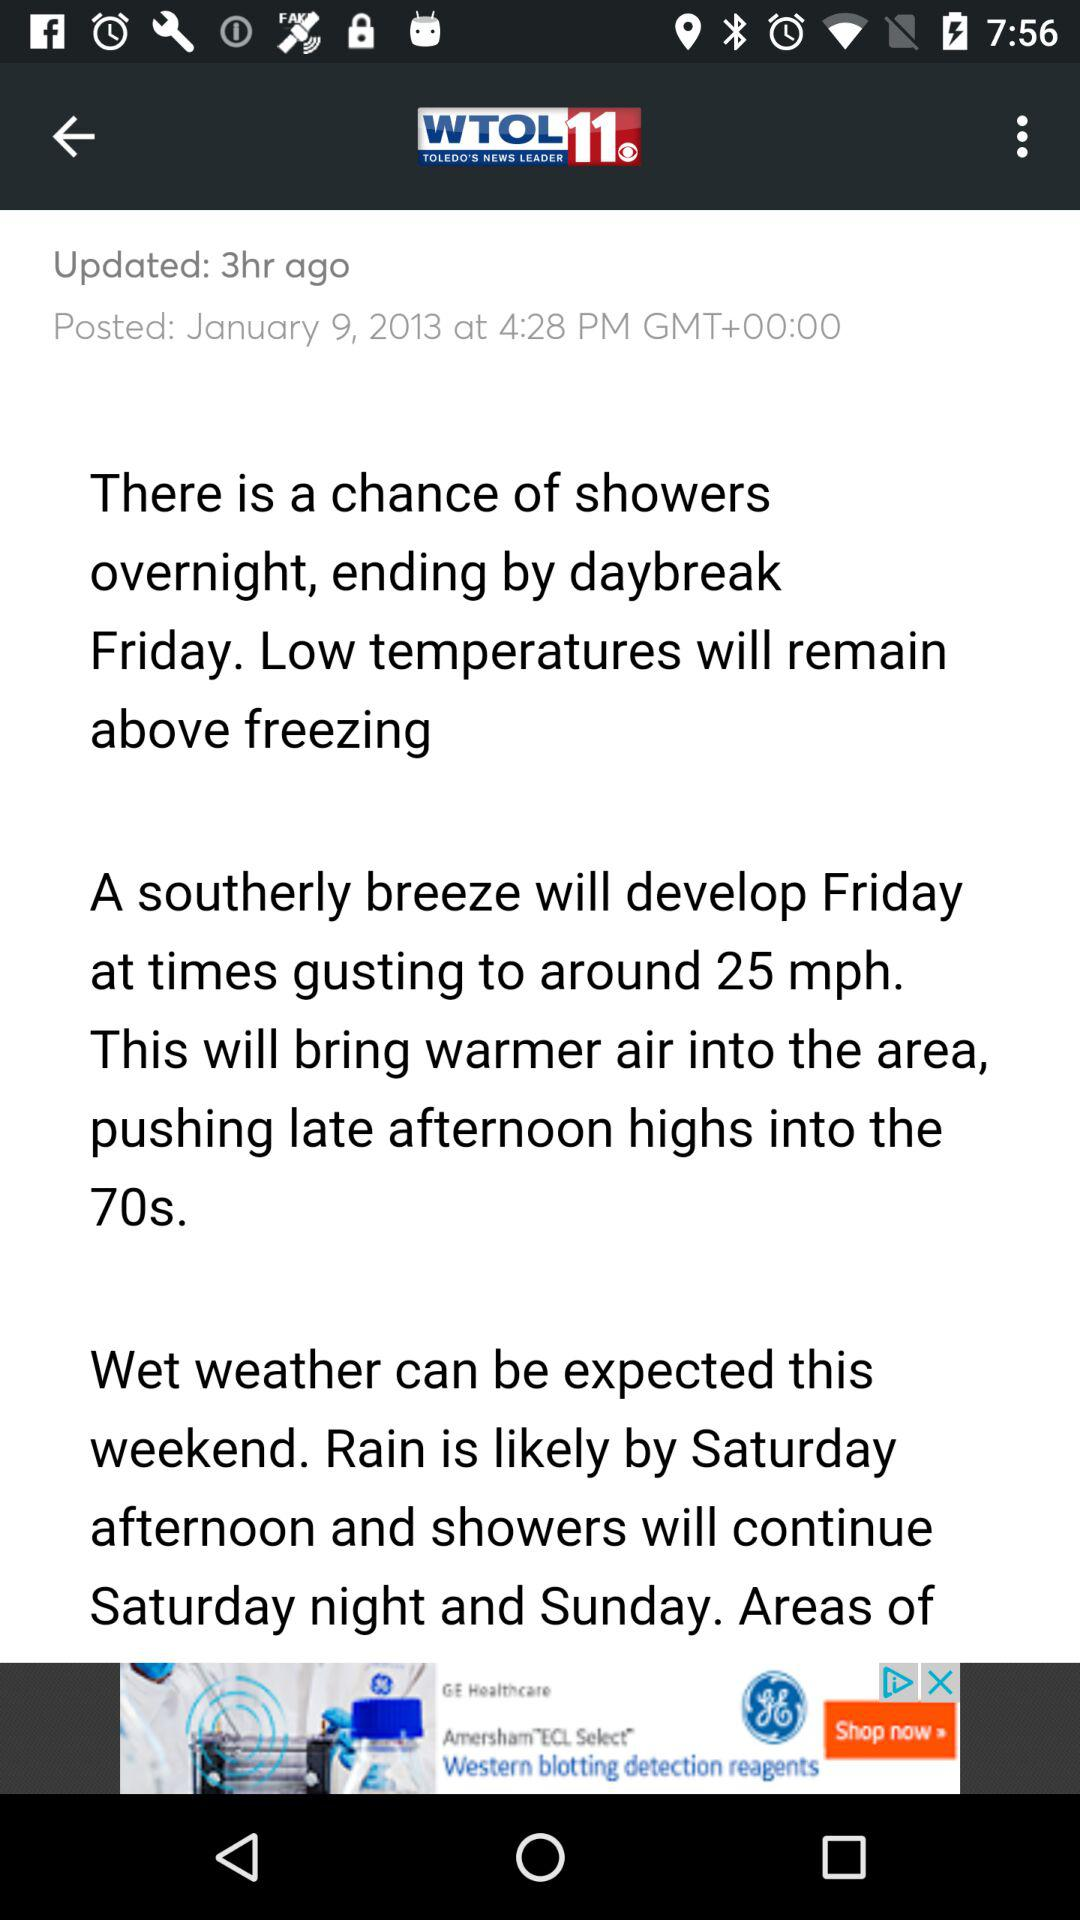What is the time? The time is 4:28 PM GMT+00:00. 